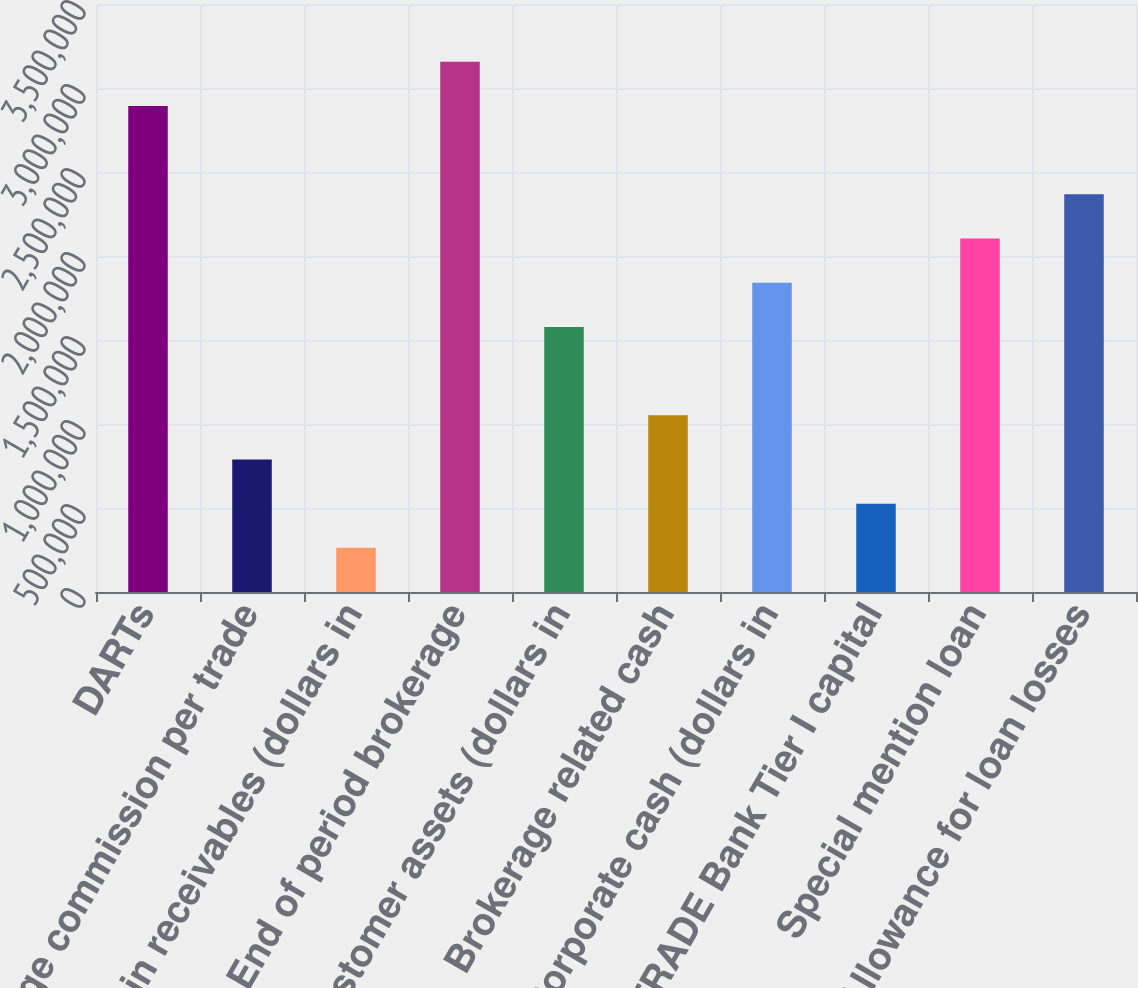Convert chart. <chart><loc_0><loc_0><loc_500><loc_500><bar_chart><fcel>DARTs<fcel>Average commission per trade<fcel>Margin receivables (dollars in<fcel>End of period brokerage<fcel>Customer assets (dollars in<fcel>Brokerage related cash<fcel>Corporate cash (dollars in<fcel>ETRADE Bank Tier I capital<fcel>Special mention loan<fcel>Allowance for loan losses<nl><fcel>2.89309e+06<fcel>789026<fcel>263010<fcel>3.15609e+06<fcel>1.57805e+06<fcel>1.05203e+06<fcel>1.84106e+06<fcel>526018<fcel>2.10406e+06<fcel>2.36707e+06<nl></chart> 